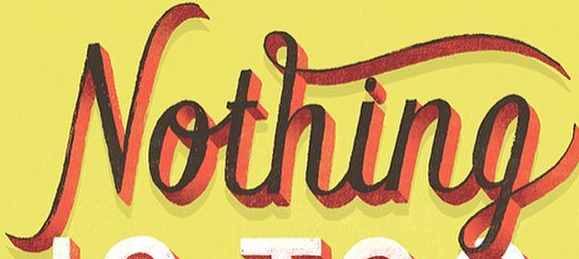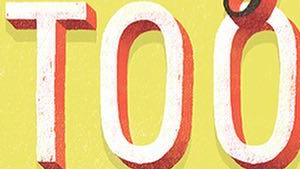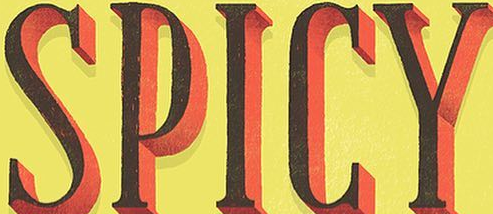What words can you see in these images in sequence, separated by a semicolon? Nothing; TOO; SPICY 